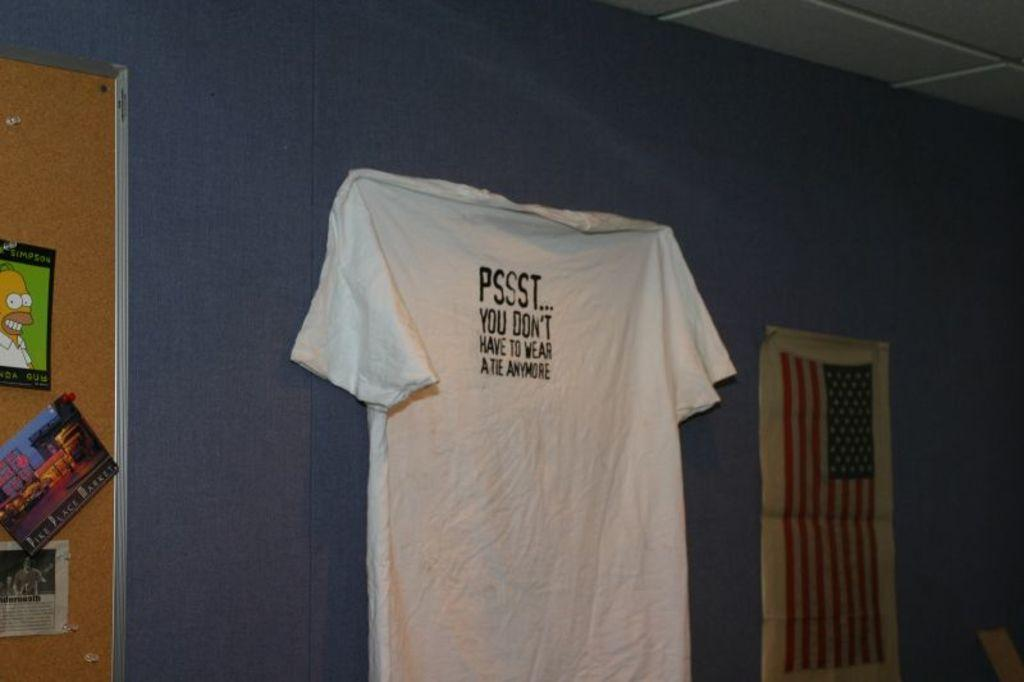<image>
Provide a brief description of the given image. A shirt that says you don't have to wear Atie anymore hangs on a wall. 